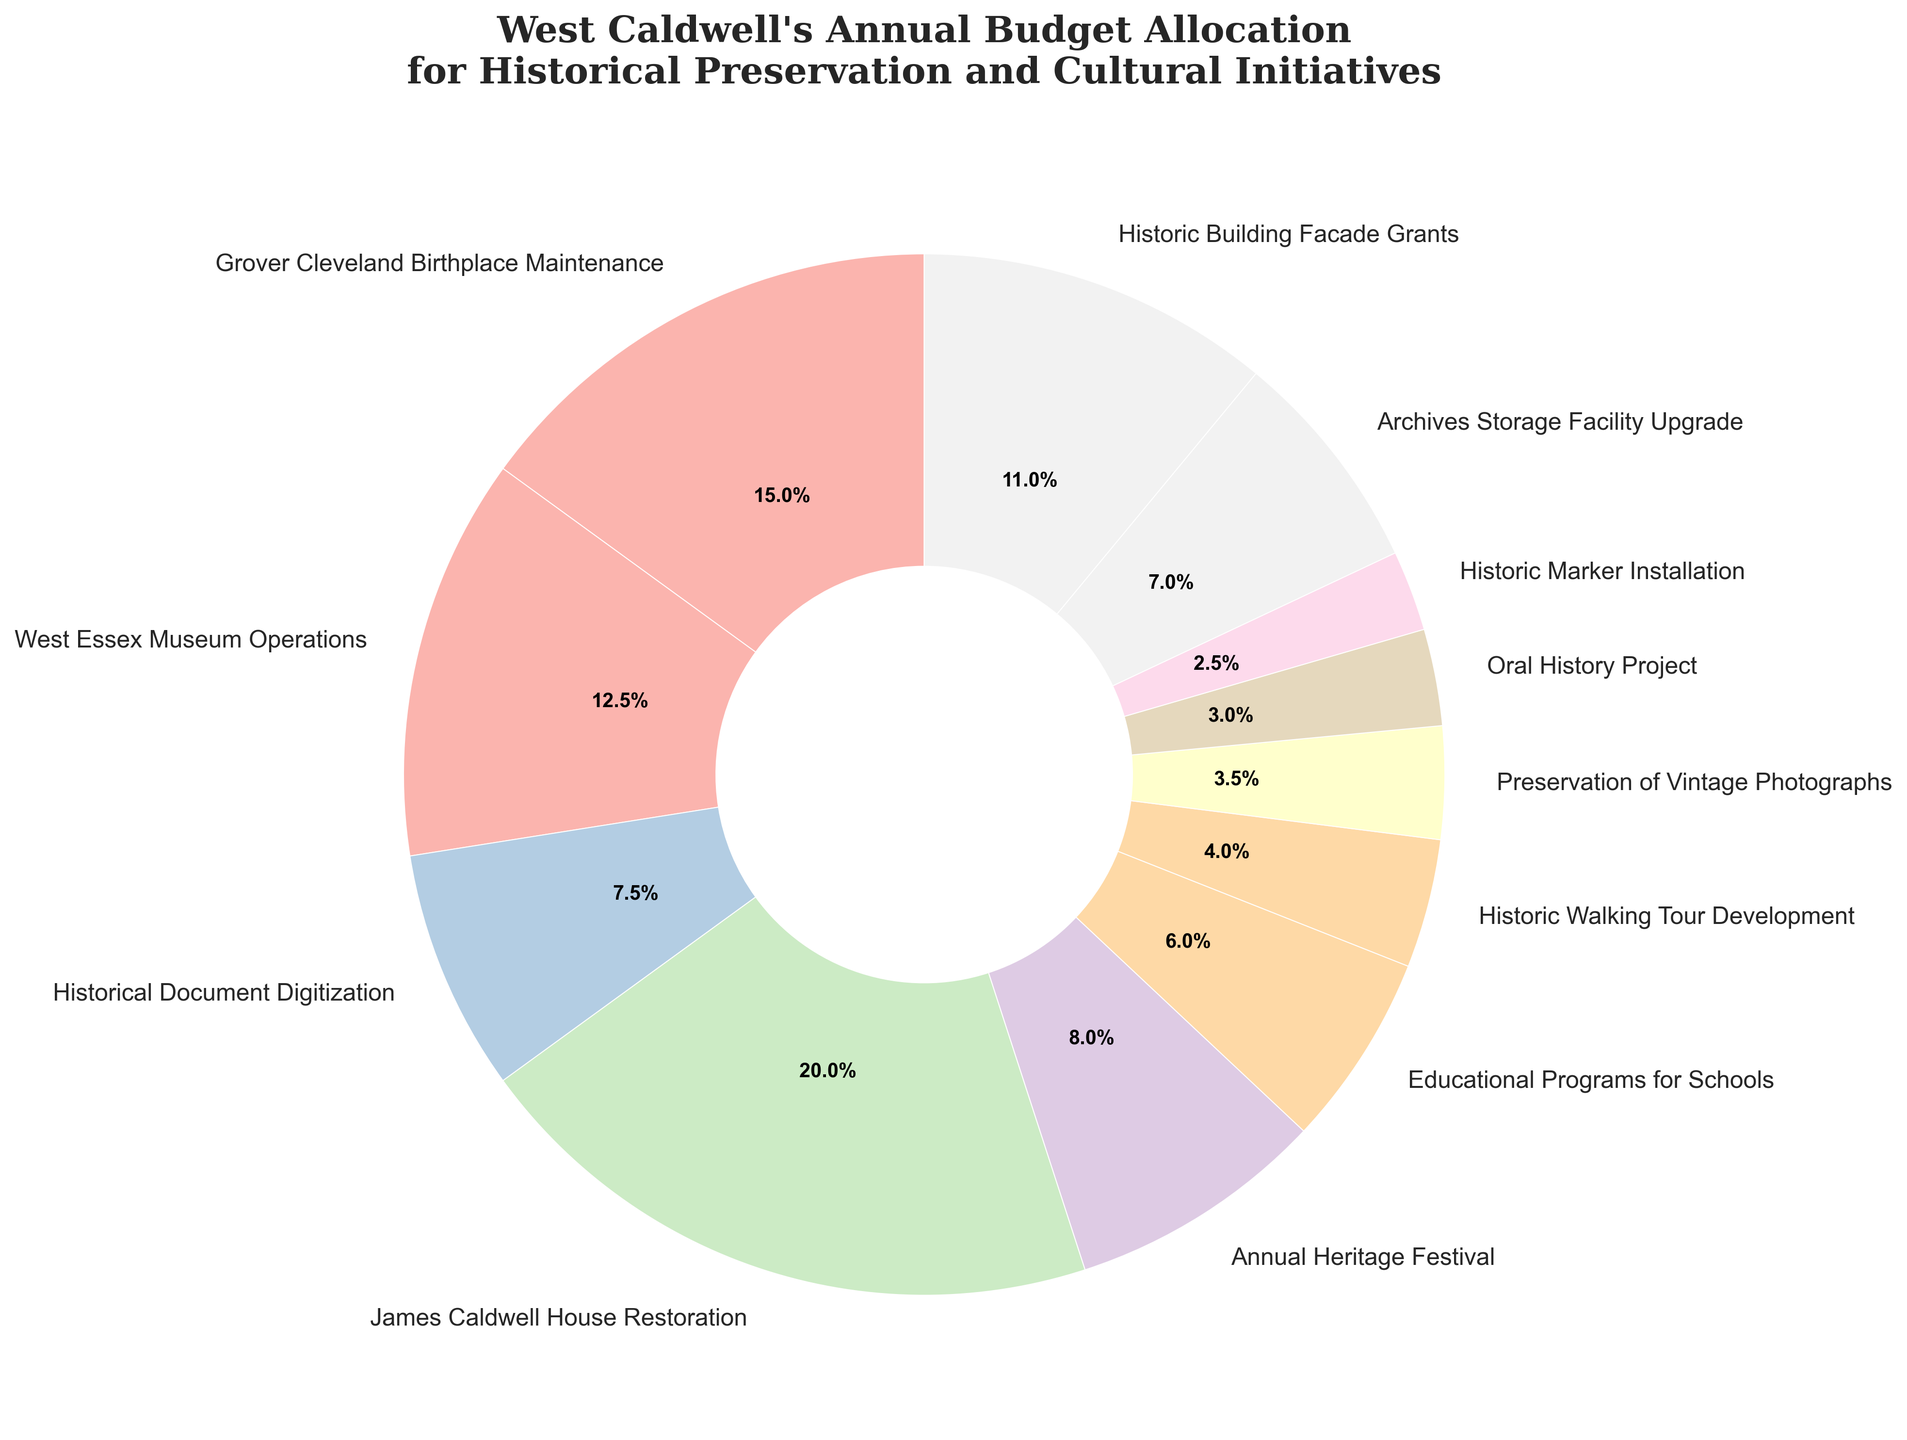What is the largest single allocation of West Caldwell's annual budget? The largest single allocation can be identified by looking at the category with the highest percentage on the pie chart. James Caldwell House Restoration stands out with the largest wedge, indicating the highest funding allocation among all categories.
Answer: James Caldwell House Restoration Which category receives the smallest percentage of the budget? To determine the smallest percentage, look for the smallest wedge in the pie chart. The Oral History Project has the smallest wedge, indicating the least budget allocation.
Answer: Oral History Project How much more is allocated to the James Caldwell House Restoration than the Educational Programs for Schools? Find the percentages or amounts given to each category. James Caldwell House Restoration receives $200,000 while Educational Programs for Schools get $60,000. The difference is $200,000 - $60,000.
Answer: $140,000 Which categories receive more funding than the Historic Walking Tour Development? The Historic Walking Tour Development gets $40,000. Identify all categories with allocations greater than $40,000: Grover Cleveland Birthplace Maintenance, West Essex Museum Operations, Historical Document Digitization, James Caldwell House Restoration, Annual Heritage Festival, Educational Programs for Schools, Preservation of Vintage Photographs, Archives Storage Facility Upgrade, Historic Building Facade Grants.
Answer: 9 categories (listed above) What percentage of the budget is allocated to Grover Cleveland Birthplace Maintenance and West Essex Museum Operations combined? Add the allocations for Grover Cleveland Birthplace Maintenance ($150,000) and West Essex Museum Operations ($125,000). Total allocation is $275,000. Calculate the percentage by dividing this sum by the total budget.
Answer: 24% Is the funding for Historic Building Facade Grants more than the combined funding for Historic Marker Installation and Oral History Project? Historic Building Facade Grants receive $110,000. The combined funding for Historic Marker Installation and Oral History Project is $25,000 + $30,000 = $55,000. Compare these values.
Answer: Yes Compare the funding difference between the Preservation of Vintage Photographs and Archives Storage Facility Upgrade. Preservation of Vintage Photographs is allocated $35,000, Archives Storage Facility Upgrade gets $70,000. The difference is $70,000 - $35,000.
Answer: $35,000 What is the total allocation for categories related to maintaining buildings and historical sites? (Grover Cleveland Birthplace, James Caldwell House, Historic Marker Installation, Historic Building Facade Grants) Sum the allocations: Grover Cleveland Birthplace Maintenance ($150,000), James Caldwell House Restoration ($200,000), Historic Marker Installation ($25,000), Historic Building Facade Grants ($110,000).
Answer: $485,000 How does the allocation for Annual Heritage Festival compare with the funding for the Historic Walking Tour Development? The Annual Heritage Festival receives $80,000, while Historic Walking Tour Development gets $40,000. The festival's funding is double that of the walking tour.
Answer: Double What percentage of the total budget is allocated to Historical Document Digitization? Find the allocation amount for Historical Document Digitization ($75,000). Calculate its percentage out of the total budget by dividing $75,000 by the total sum of all allocations.
Answer: 7.5% 